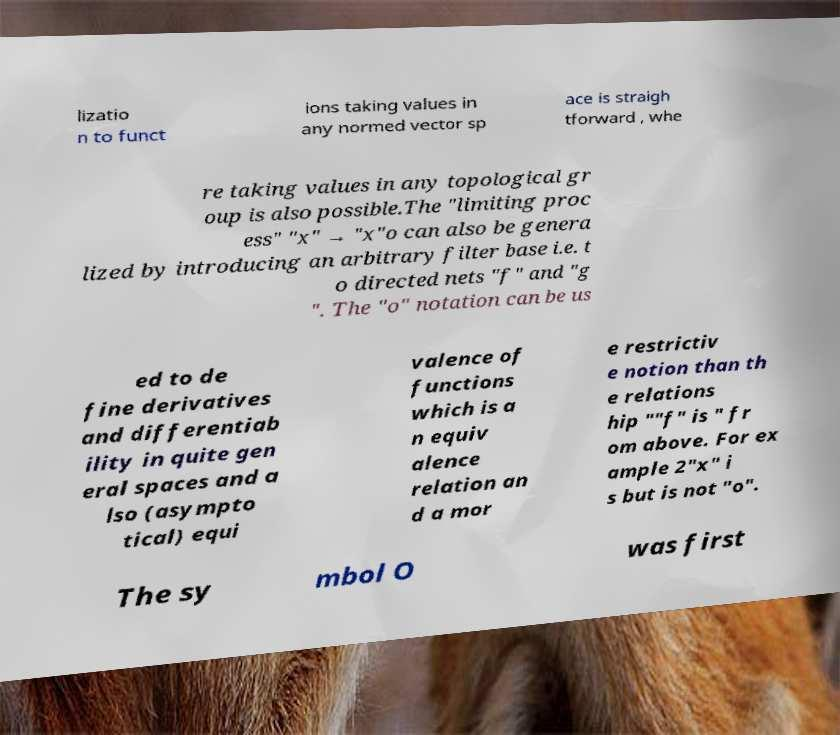Could you extract and type out the text from this image? lizatio n to funct ions taking values in any normed vector sp ace is straigh tforward , whe re taking values in any topological gr oup is also possible.The "limiting proc ess" "x" → "x"o can also be genera lized by introducing an arbitrary filter base i.e. t o directed nets "f" and "g ". The "o" notation can be us ed to de fine derivatives and differentiab ility in quite gen eral spaces and a lso (asympto tical) equi valence of functions which is a n equiv alence relation an d a mor e restrictiv e notion than th e relations hip ""f" is " fr om above. For ex ample 2"x" i s but is not "o". The sy mbol O was first 